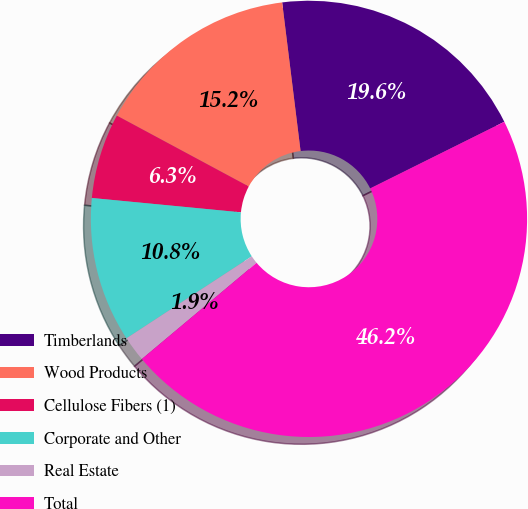Convert chart. <chart><loc_0><loc_0><loc_500><loc_500><pie_chart><fcel>Timberlands<fcel>Wood Products<fcel>Cellulose Fibers (1)<fcel>Corporate and Other<fcel>Real Estate<fcel>Total<nl><fcel>19.62%<fcel>15.19%<fcel>6.32%<fcel>10.75%<fcel>1.88%<fcel>46.24%<nl></chart> 